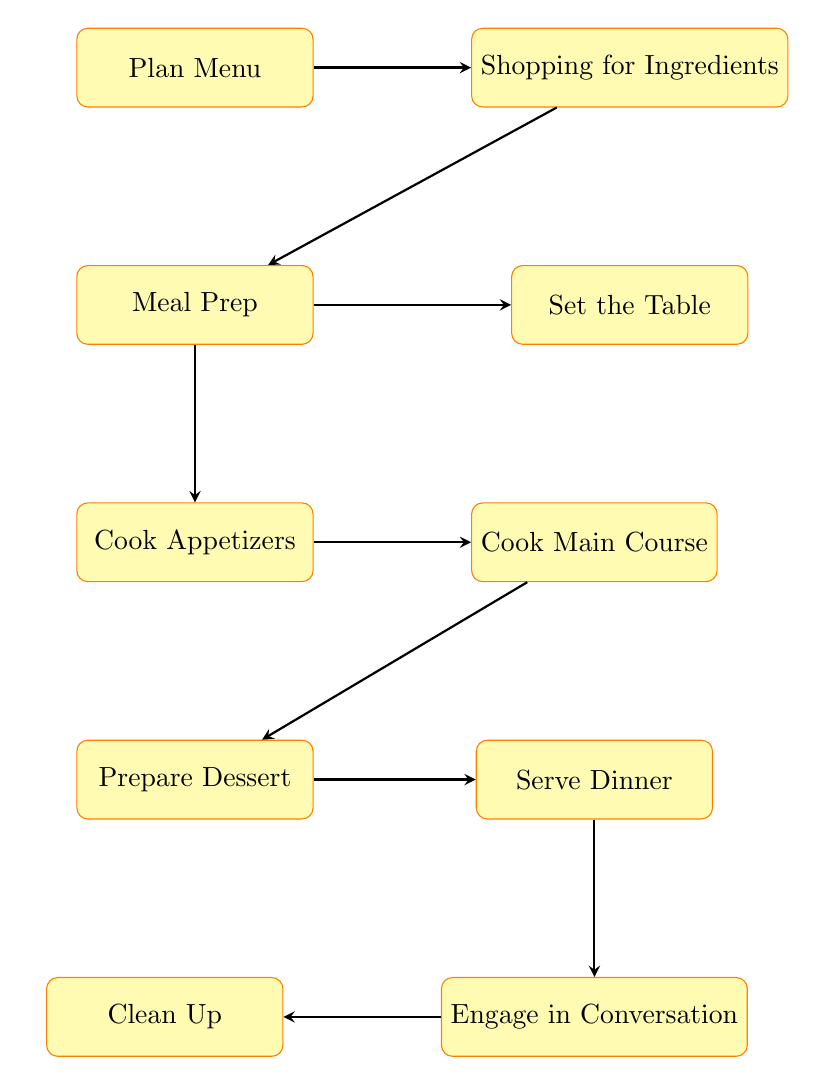What is the first step in the flow chart? The first step is "Plan Menu," which is located at the top of the diagram. This node indicates the initiation of the meal preparation process.
Answer: Plan Menu How many nodes are present in the diagram? The diagram contains ten nodes representing different steps in the dinner party preparation process. Each node corresponds to a specific action that needs to be taken.
Answer: Ten What comes after “Meal Prep”? After "Meal Prep," the next step is "Cook Appetizers." The arrows in the flow chart indicate the progression from one step to the next.
Answer: Cook Appetizers Which node is the last step in the flow chart? The last step is "Clean Up." It is the final node in the flow chart after all the dinner activities have taken place.
Answer: Clean Up What two processes occur after “Cook Main Course”? Following "Cook Main Course," the two processes are "Prepare Dessert" and "Serve Dinner." The diagram branches out after the main course to include dessert preparation and serving.
Answer: Prepare Dessert, Serve Dinner What action is performed before setting the table? Before "Set the Table," the action taken is "Shopping for Ingredients." This step involves gathering supplies needed for the meal preparation process.
Answer: Shopping for Ingredients Which process directly follows “Serve Dinner”? Directly following "Serve Dinner" is "Engage in Conversation." The diagram indicates that after serving, the next activity is social engagement with the guests.
Answer: Engage in Conversation How is “Cook Appetizers” related to “Meal Prep”? "Cook Appetizers" is a subsequent step that follows directly from "Meal Prep." The flow chart shows an arrow leading from "Meal Prep" to "Cook Appetizers," indicating this relationship.
Answer: Subsequent step 